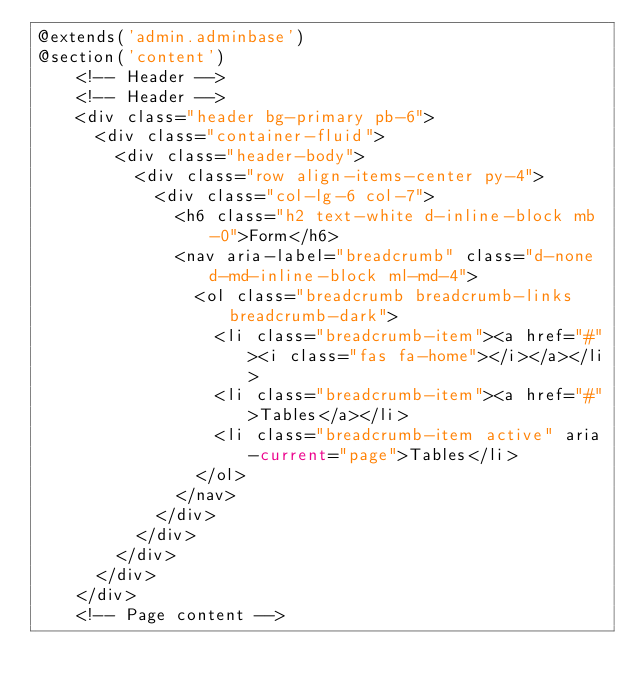<code> <loc_0><loc_0><loc_500><loc_500><_PHP_>@extends('admin.adminbase')
@section('content')    
    <!-- Header -->
    <!-- Header -->
    <div class="header bg-primary pb-6">
      <div class="container-fluid">
        <div class="header-body">
          <div class="row align-items-center py-4">
            <div class="col-lg-6 col-7">
              <h6 class="h2 text-white d-inline-block mb-0">Form</h6>
              <nav aria-label="breadcrumb" class="d-none d-md-inline-block ml-md-4">
                <ol class="breadcrumb breadcrumb-links breadcrumb-dark">
                  <li class="breadcrumb-item"><a href="#"><i class="fas fa-home"></i></a></li>
                  <li class="breadcrumb-item"><a href="#">Tables</a></li>
                  <li class="breadcrumb-item active" aria-current="page">Tables</li>
                </ol>
              </nav>
            </div>
          </div>
        </div>
      </div>
    </div>
    <!-- Page content --></code> 